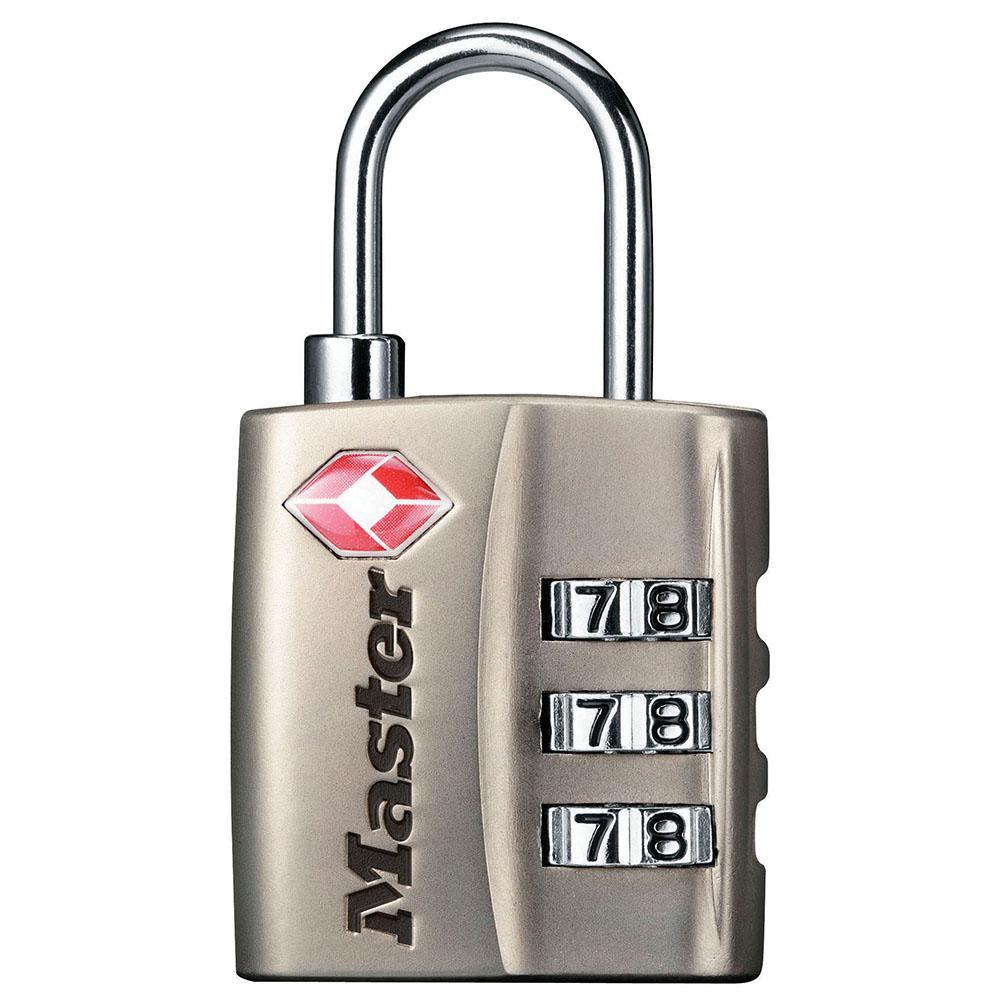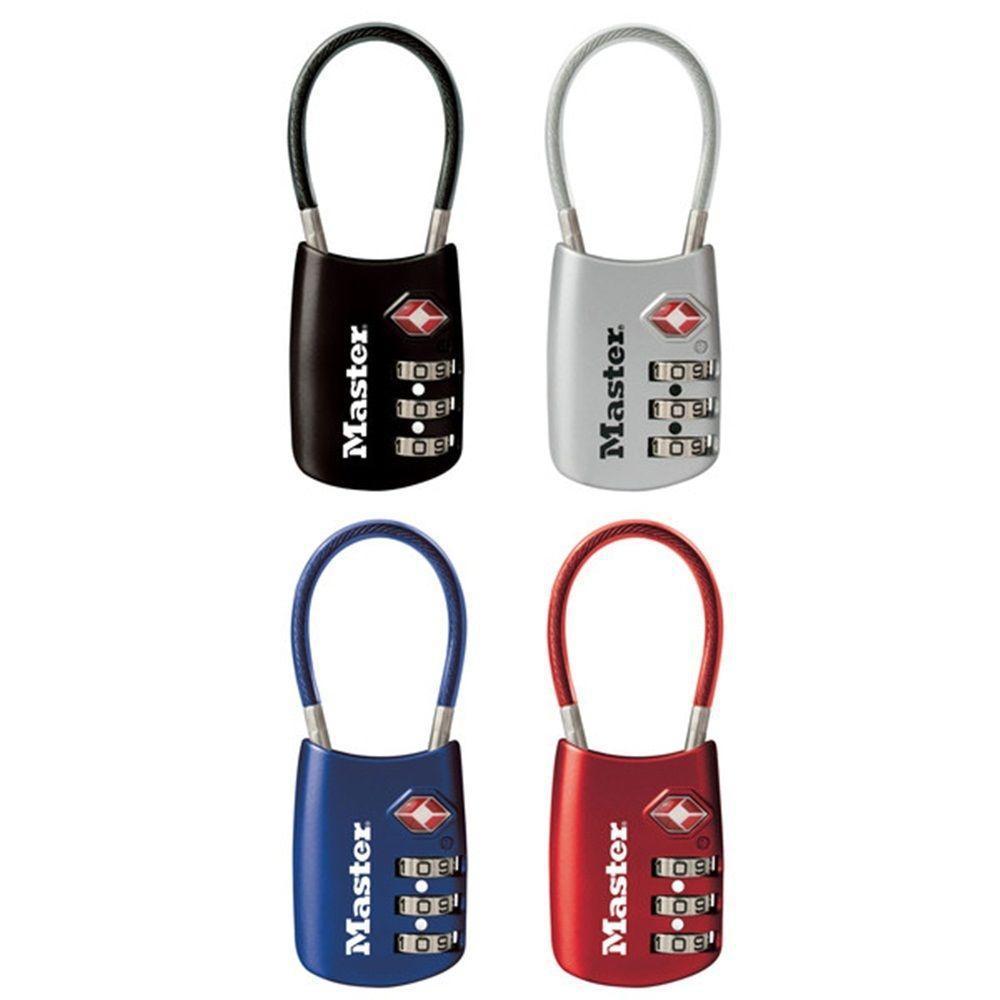The first image is the image on the left, the second image is the image on the right. Examine the images to the left and right. Is the description "All of the locks have black bodies with a metal ring." accurate? Answer yes or no. No. The first image is the image on the left, the second image is the image on the right. Assess this claim about the two images: "All combination locks have black bodies with silver lock loops at the top, and black numbers on sliding silver number belts.". Correct or not? Answer yes or no. No. 